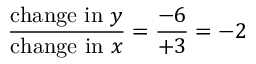Convert formula to latex. <formula><loc_0><loc_0><loc_500><loc_500>{ \frac { { c h a n g e i n } y } { { c h a n g e i n } x } } = { \frac { - 6 } { + 3 } } = - 2</formula> 